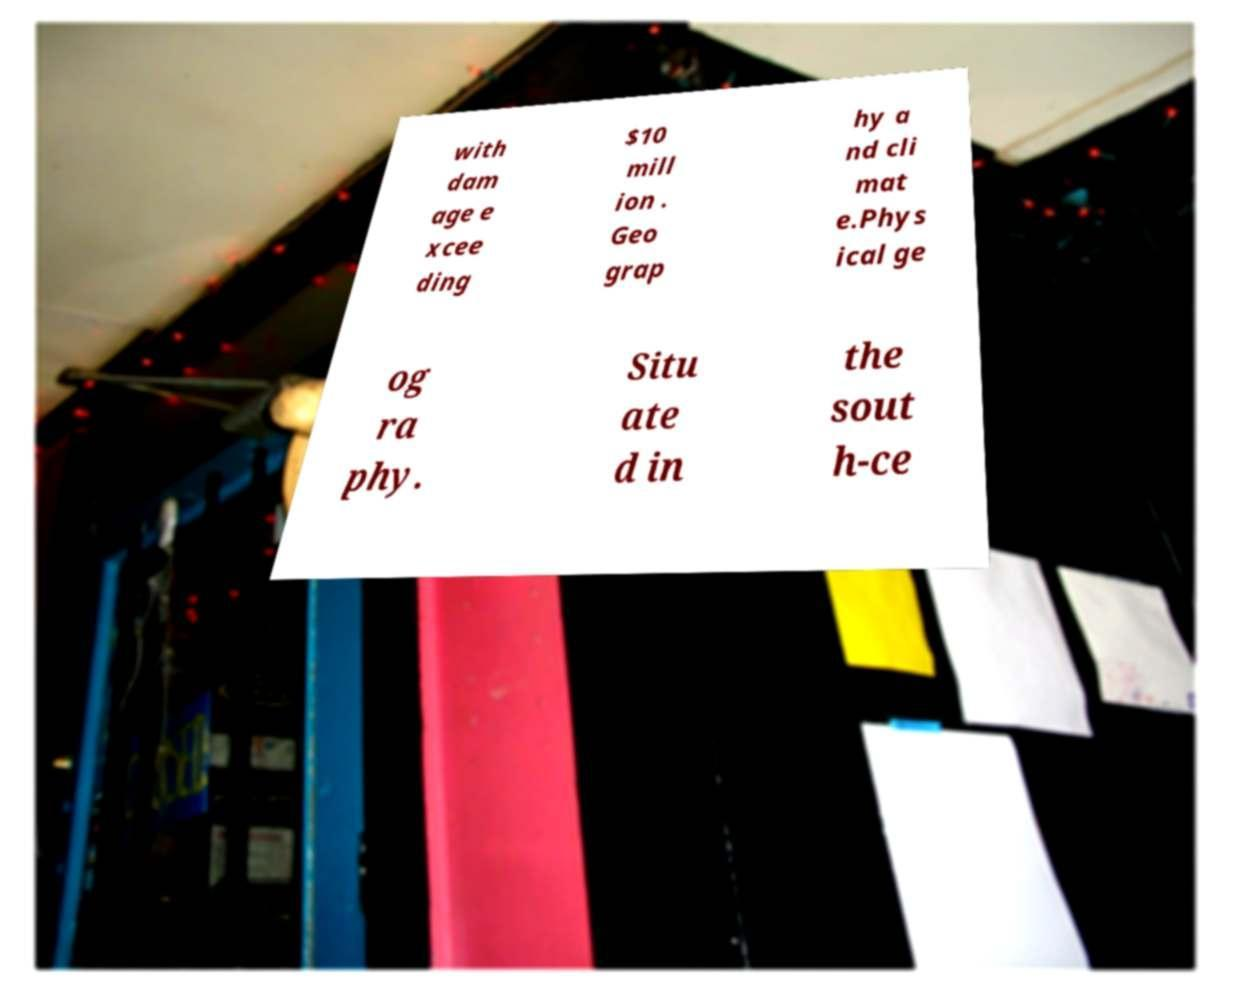Could you extract and type out the text from this image? with dam age e xcee ding $10 mill ion . Geo grap hy a nd cli mat e.Phys ical ge og ra phy. Situ ate d in the sout h-ce 